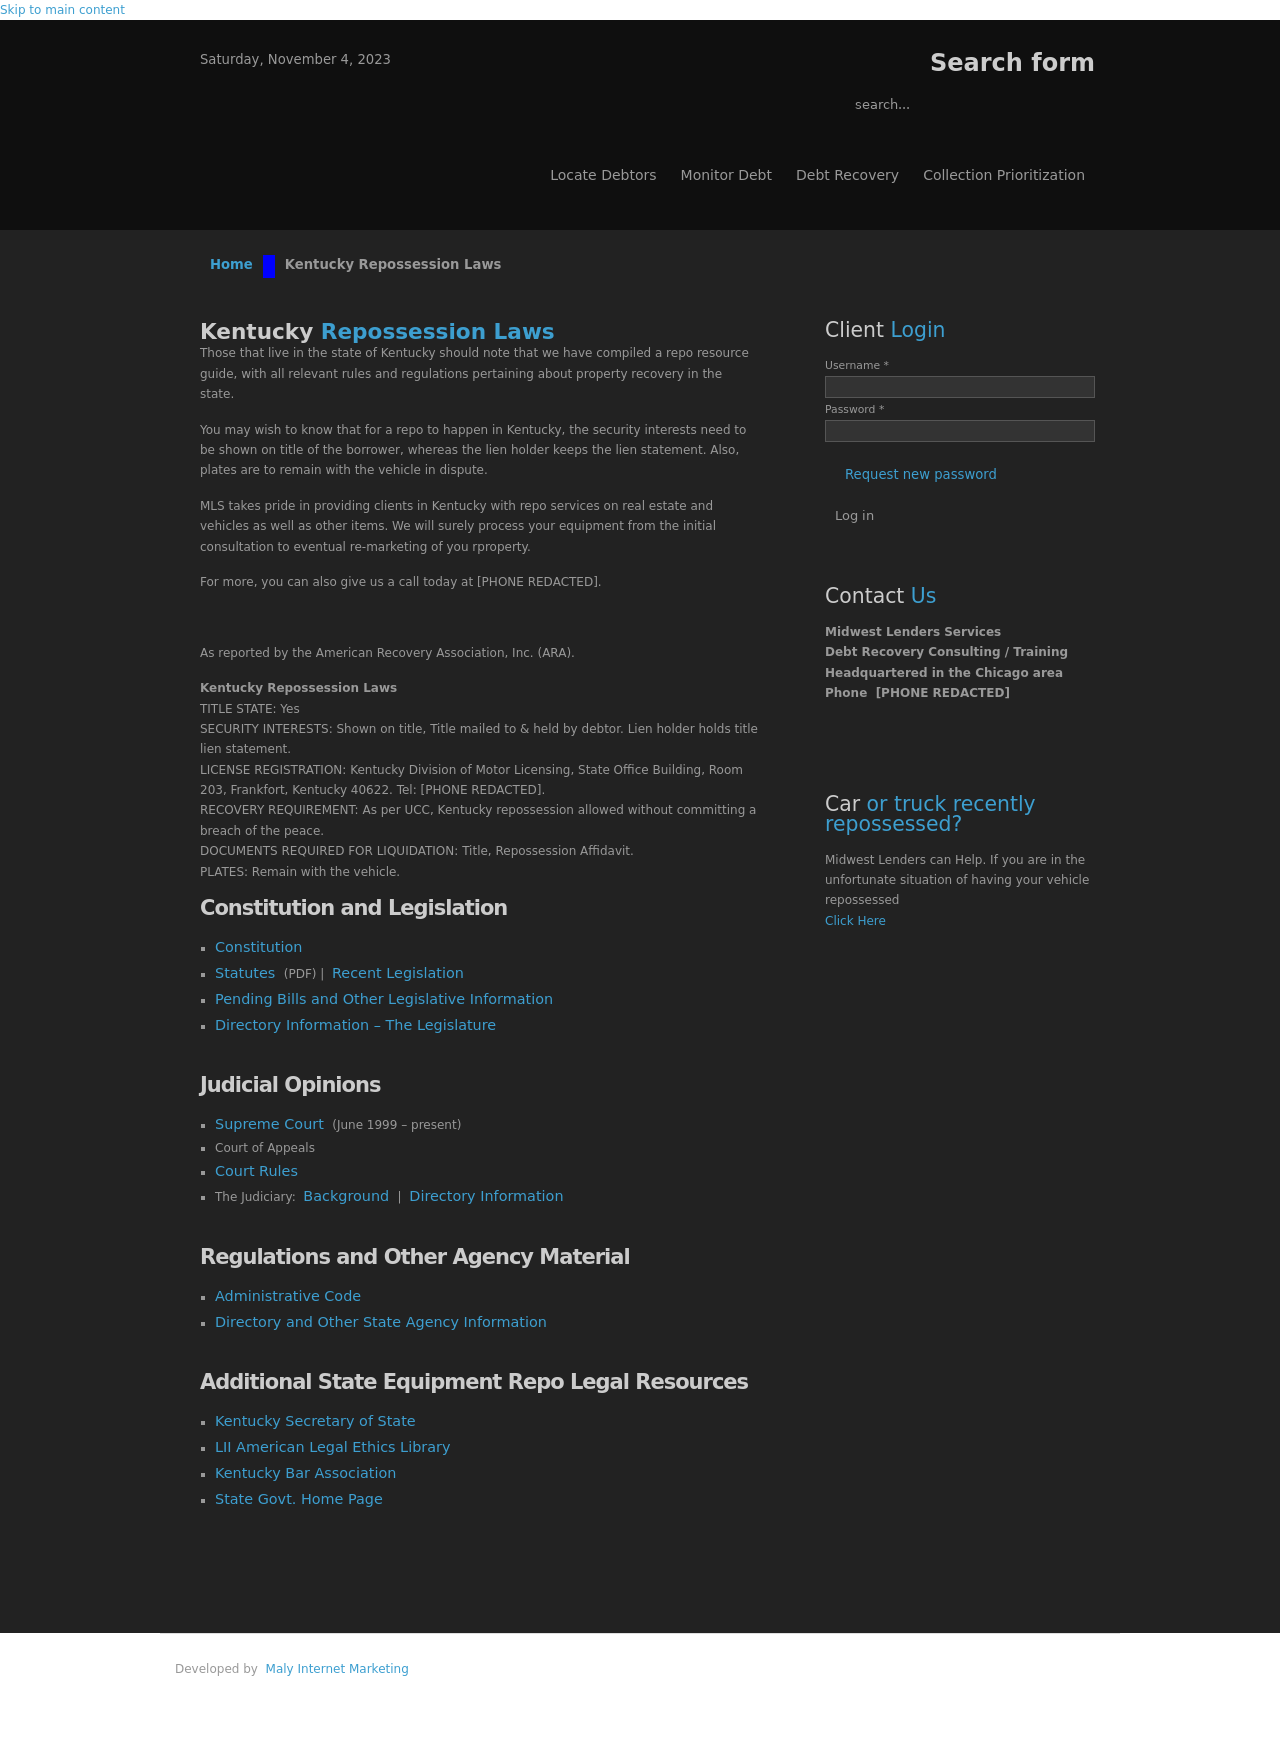Could you guide me through the process of developing this website with HTML? Certainly! The first step in creating a website like the one shown in the image is to understand the structure and content. This specific site includes sections like 'Home', 'Kentucky Repossession Laws', 'Client Login', and various informational sections. To start: 
1. Define the HTML structure with sections (`<section>` tags) for each part. 
2. Use `<header>`, `<nav>`, and `<footer>` for semantic layout. 
3. Style with CSS for layout and design, similar to the grayscale aesthetic shown. 
4. I'll also focus on including forms for user interactions, like the login panel. 